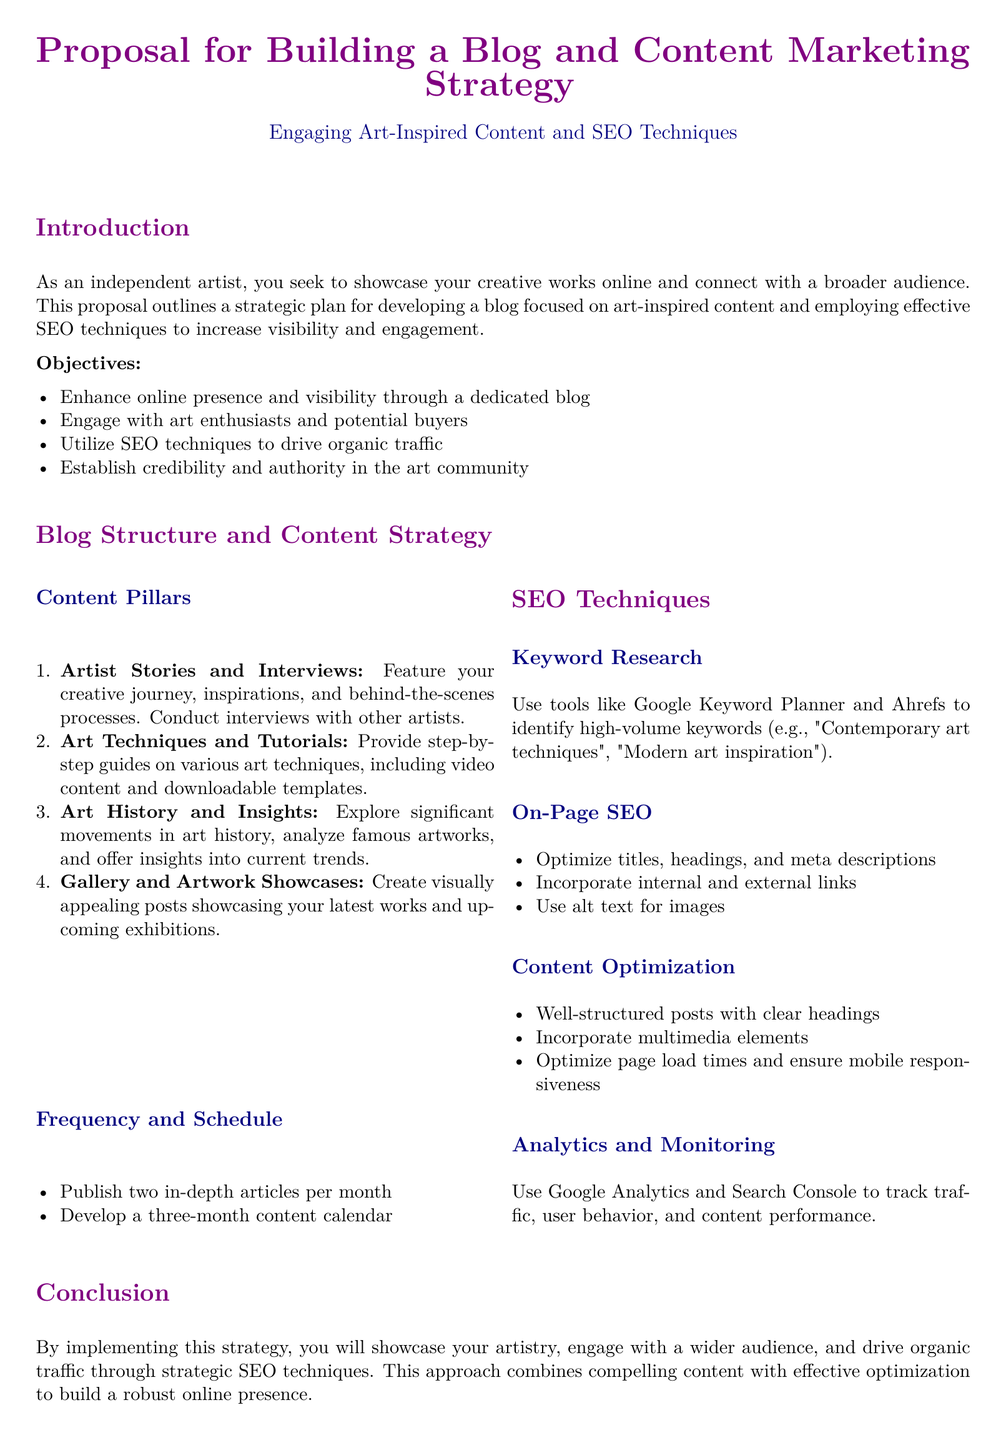What is the primary goal of the proposal? The primary goal is to outline a strategic plan for developing a blog focused on art-inspired content and SEO techniques.
Answer: Outline a strategic plan How many content pillars are identified in the document? The document lists four content pillars for the blog.
Answer: Four What types of articles are suggested to be published per month? The proposal recommends publishing two in-depth articles each month.
Answer: Two in-depth articles Which tools are mentioned for keyword research? Google Keyword Planner and Ahrefs are mentioned as tools for keyword research.
Answer: Google Keyword Planner and Ahrefs What is the expected focus of the blog’s content? The blog's content is expected to focus on engaging art-inspired topics.
Answer: Engaging art-inspired topics What kind of analytics tools should be used for monitoring? Google Analytics and Search Console should be used to track performance.
Answer: Google Analytics and Search Console What is the purpose of incorporating multimedia elements? Incorporating multimedia elements aims to enhance content optimization and engagement.
Answer: Enhance content optimization and engagement How long is the proposed content calendar? The proposal suggests developing a three-month content calendar.
Answer: Three months What section discusses the optimization of titles and headings? The section on On-Page SEO discusses the optimization of titles and headings.
Answer: On-Page SEO 